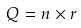Convert formula to latex. <formula><loc_0><loc_0><loc_500><loc_500>Q = n \times r</formula> 